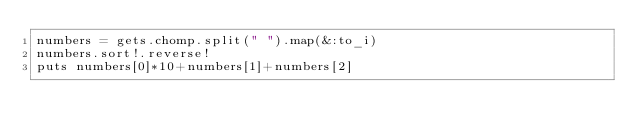Convert code to text. <code><loc_0><loc_0><loc_500><loc_500><_Ruby_>numbers = gets.chomp.split(" ").map(&:to_i)
numbers.sort!.reverse!
puts numbers[0]*10+numbers[1]+numbers[2]</code> 